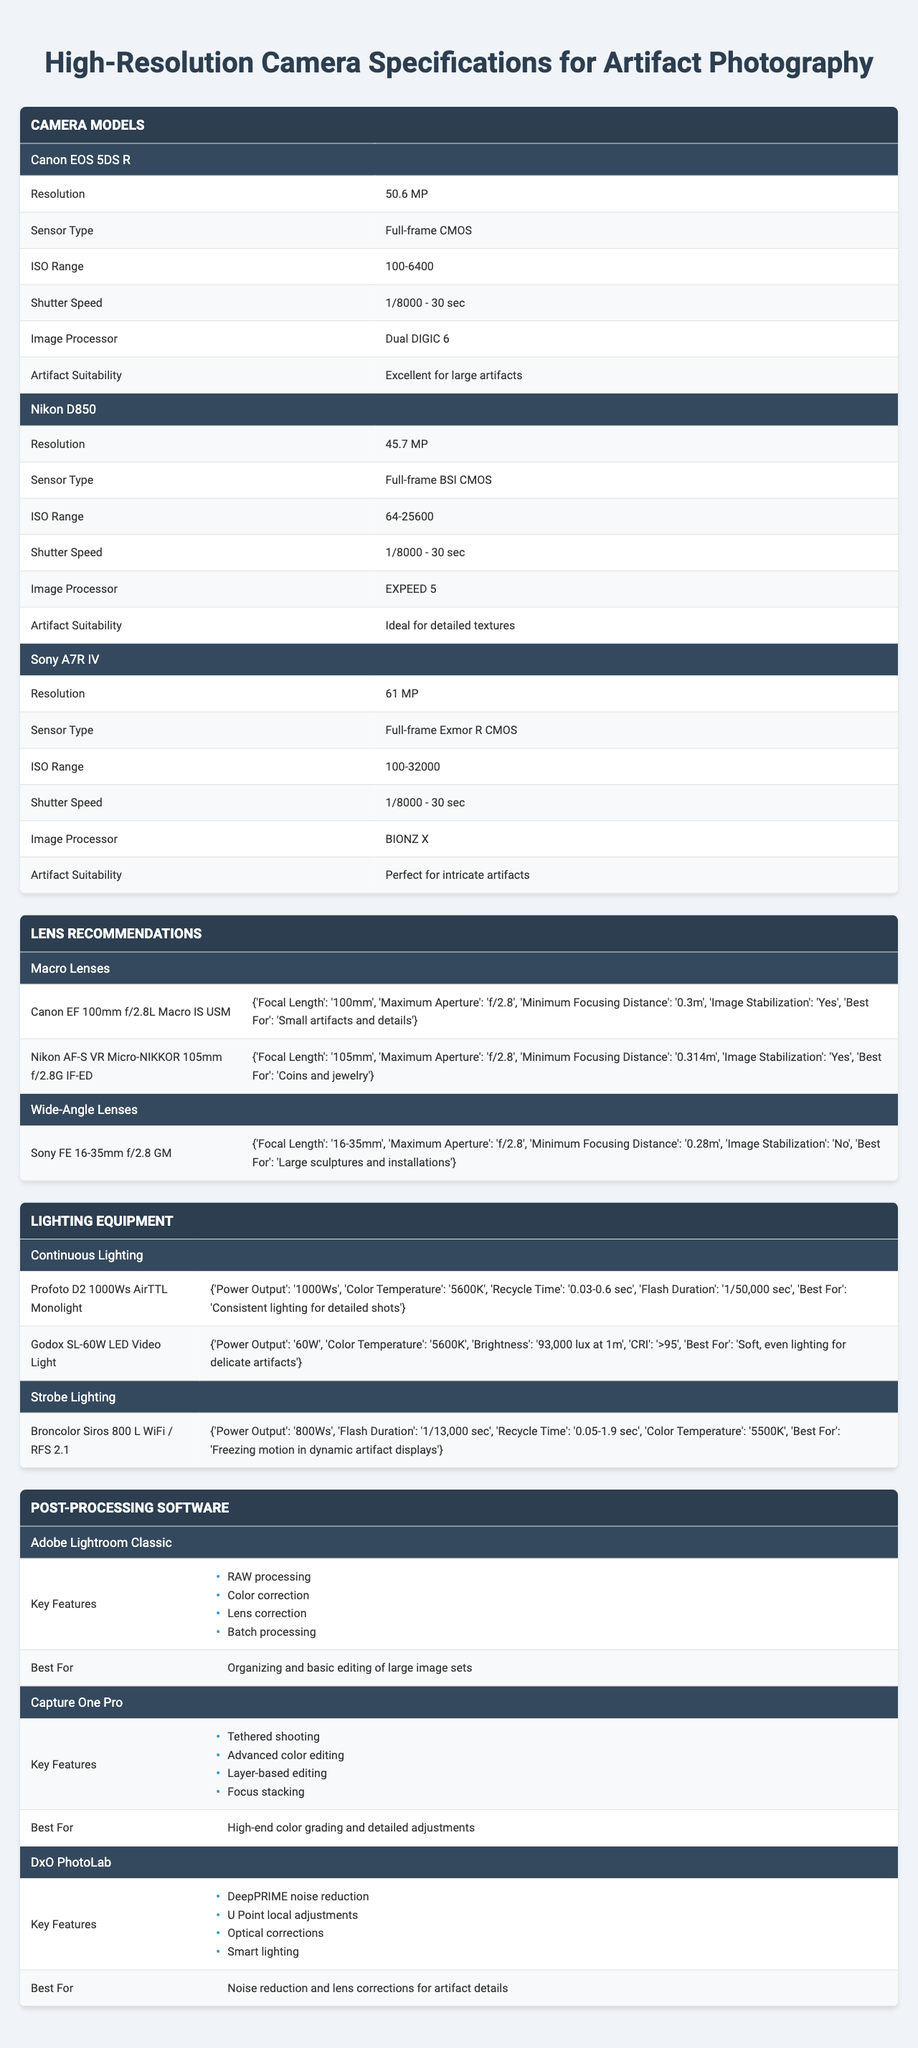What is the resolution of the Canon EOS 5DS R? The table lists the specifications of different camera models, and under the Canon EOS 5DS R, the resolution is stated as 50.6 MP.
Answer: 50.6 MP What is the ISO range of the Nikon D850? By referring to the specifications of the Nikon D850 in the table, the ISO range is clearly indicated as 64-25600.
Answer: 64-25600 Which camera model has the highest resolution? By comparing the resolution values of the three listed camera models, the Sony A7R IV has the highest resolution at 61 MP.
Answer: Sony A7R IV Do all cameras listed have a shutter speed range of 1/8000 - 30 sec? A quick review of the shutter speed specifications shows that all listed camera models have the same range of 1/8000 - 30 sec.
Answer: Yes What is the maximum aperture of the Canon EF 100mm f/2.8L Macro IS USM lens? The specifications for the Canon EF 100mm f/2.8L Macro IS USM lens reveal that its maximum aperture is f/2.8.
Answer: f/2.8 Which type of lighting equipment is best for consistent lighting for detailed shots? The table indicates that the Profoto D2 1000Ws AirTTL Monolight is best for consistent lighting for detailed shots, as stated in its specifications.
Answer: Profoto D2 1000Ws AirTTL Monolight How many key features does the Capture One Pro software have? The Capture One Pro software has four key features listed in the table, which are tethered shooting, advanced color editing, layer-based editing, and focus stacking.
Answer: 4 Select a camera suitable for intricate artifacts and explain why it’s suitable. The Sony A7R IV is noted as perfect for intricate artifacts in the table due to its high resolution of 61 MP and sensor type designed for capturing detailed images.
Answer: Sony A7R IV Which lens is recommended for photographing coins and jewelry? The Nikon AF-S VR Micro-NIKKOR 105mm f/2.8G IF-ED is recommended for photographing coins and jewelry as specified under the lens recommendations section.
Answer: Nikon AF-S VR Micro-NIKKOR 105mm f/2.8G IF-ED Is the Godox SL-60W LED Video Light image stabilizing? The specifications indicate that the Godox SL-60W LED Video Light does not have image stabilization listed.
Answer: No What are the color temperatures for the continuous lighting options? The two options for continuous lighting, Profoto D2 and Godox SL-60W, both have a color temperature of approximately 5600K as indicated in their specifications.
Answer: 5600K 